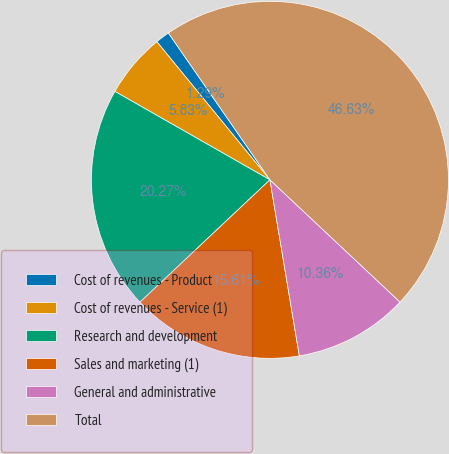Convert chart to OTSL. <chart><loc_0><loc_0><loc_500><loc_500><pie_chart><fcel>Cost of revenues - Product<fcel>Cost of revenues - Service (1)<fcel>Research and development<fcel>Sales and marketing (1)<fcel>General and administrative<fcel>Total<nl><fcel>1.29%<fcel>5.83%<fcel>20.27%<fcel>15.61%<fcel>10.36%<fcel>46.63%<nl></chart> 